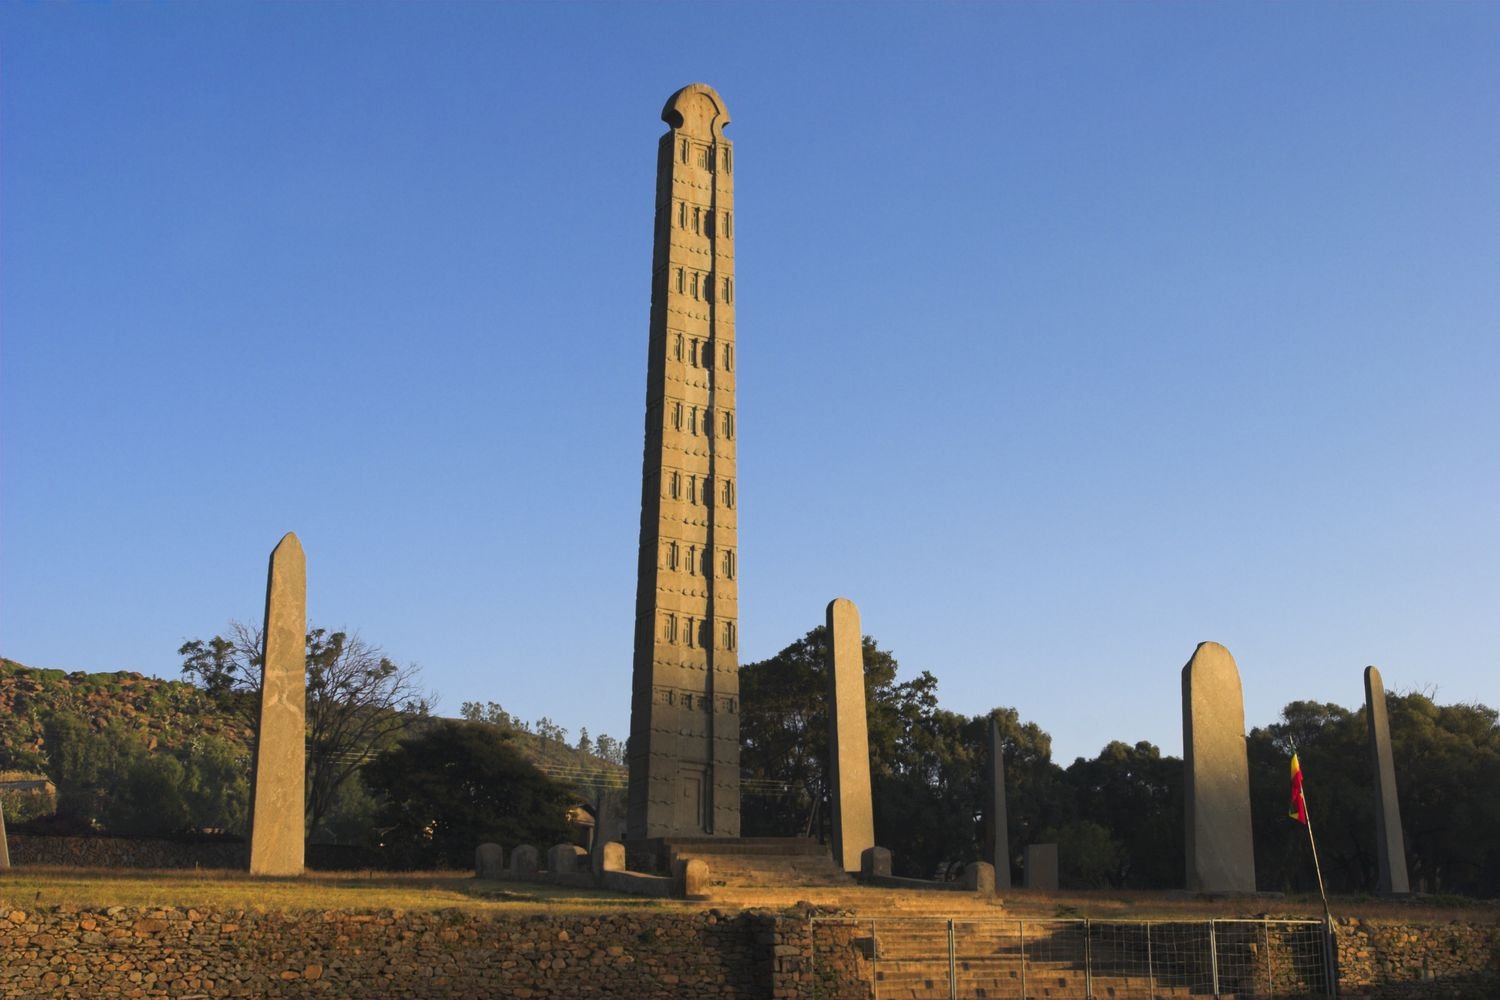What can you tell me about the historical significance of this structure? The Obelisk of Axum is a striking example of ancient engineering and a symbol of the powerful Kingdom of Aksum, one of the most influential civilizations of the ancient world. Dating back to the 4th century AD, this obelisk and its counterparts served as both grave markers for the elite and as symbols of the Aksumite Empire’s strength and craftsmanship. The intricate carvings and imposing height reflect the sophisticated architectural skills and cultural richness of the Aksumites. The Obelisk of Aksum also represents Ethiopia’s deep historical roots and its significance in early Christian history, as Aksum was one of the first major empires to embrace Christianity. What were the obelisks used for during the Aksumite Empire? The obelisks, including the prominent Obelisk of Axum, were primarily used as grave markers for royalty and nobility during the Aksumite Empire. They were part of elaborate funerary practices, symbolizing the social status and power of the deceased. These towering monuments were also believed to connect the earthly realm with the divine, marking sacred spaces. The carvings that mimic architectural elements such as windows and doors were intended to represent the civil status of the individual, suggesting an eternal dwelling place post-mortem. 